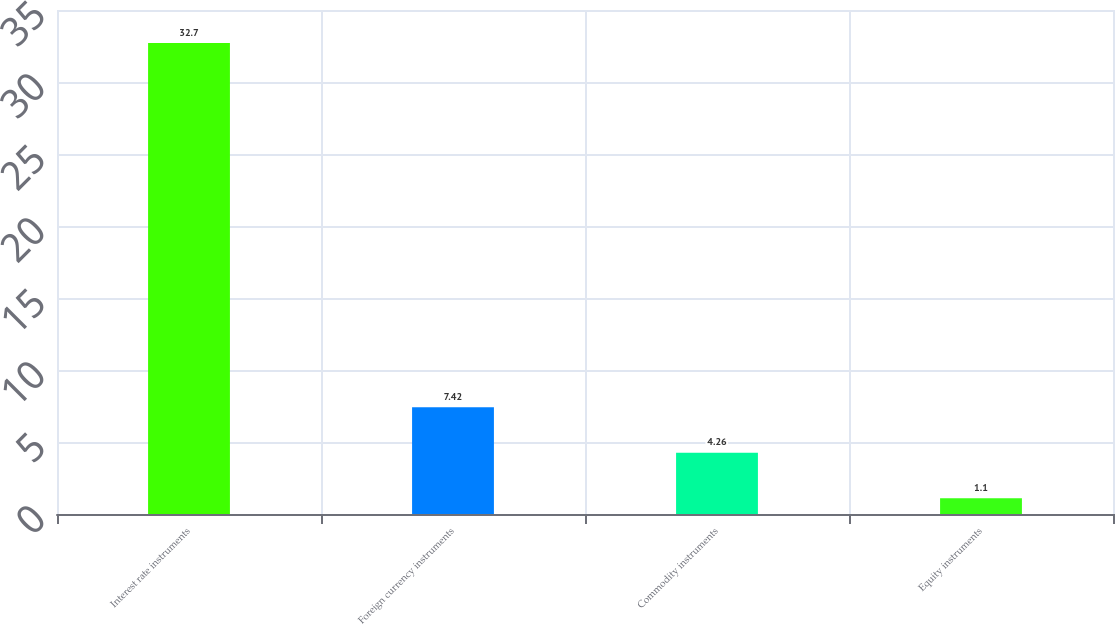Convert chart. <chart><loc_0><loc_0><loc_500><loc_500><bar_chart><fcel>Interest rate instruments<fcel>Foreign currency instruments<fcel>Commodity instruments<fcel>Equity instruments<nl><fcel>32.7<fcel>7.42<fcel>4.26<fcel>1.1<nl></chart> 